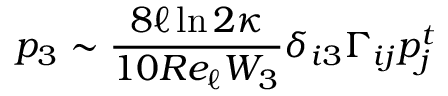<formula> <loc_0><loc_0><loc_500><loc_500>p _ { 3 } \sim \frac { 8 \ell \ln { 2 \kappa } } { 1 0 R e _ { \ell } W _ { 3 } } \delta _ { i 3 } \Gamma _ { i j } p _ { j } ^ { t }</formula> 